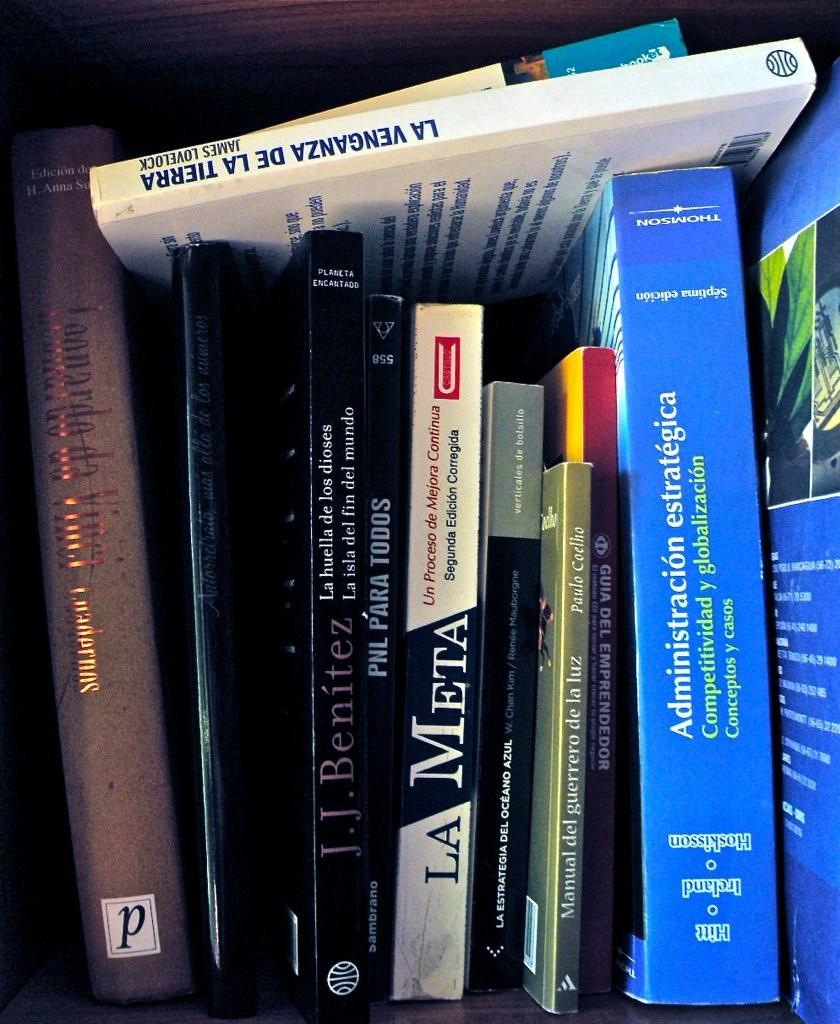How many books are in the photo?
Make the answer very short. Answering does not require reading text in the image. What single letter can you see on the very left book?
Keep it short and to the point. P. 